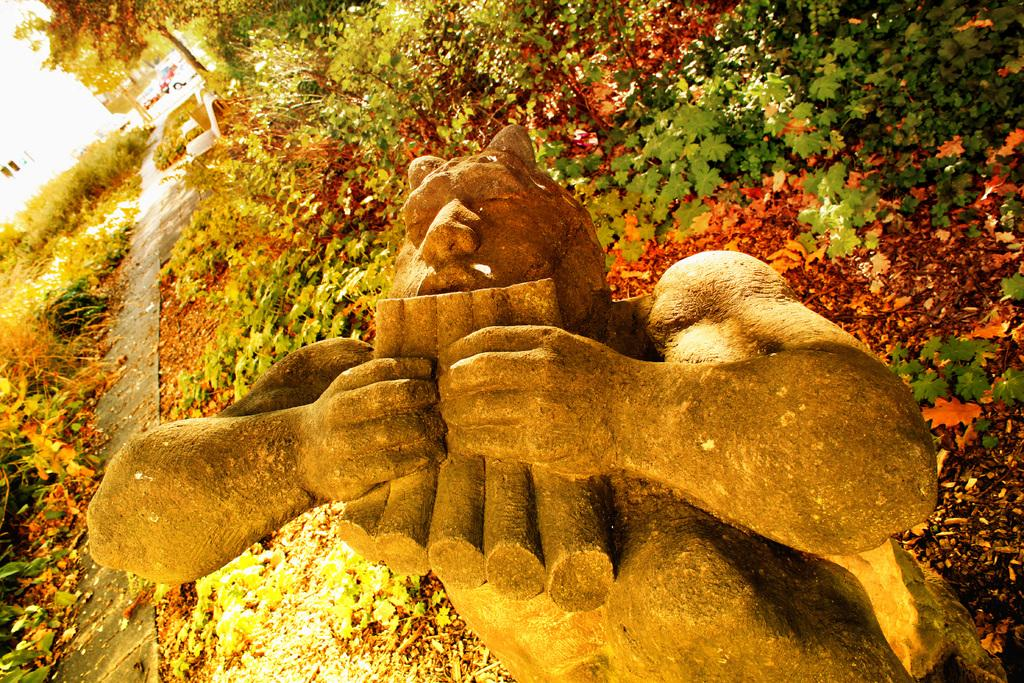What is the main subject in the foreground of the image? There is a sculpture in the foreground of the image. What else is present in the foreground of the image? There are plants in the foreground of the image. What can be seen in the background of the image? There are trees, buildings, and vehicles on the road in the background of the image. Can you describe the setting of the image? The image may have been taken in a park, given the presence of plants and trees. How many dogs are sitting on the floor in the image? There are no dogs or floors present in the image. 